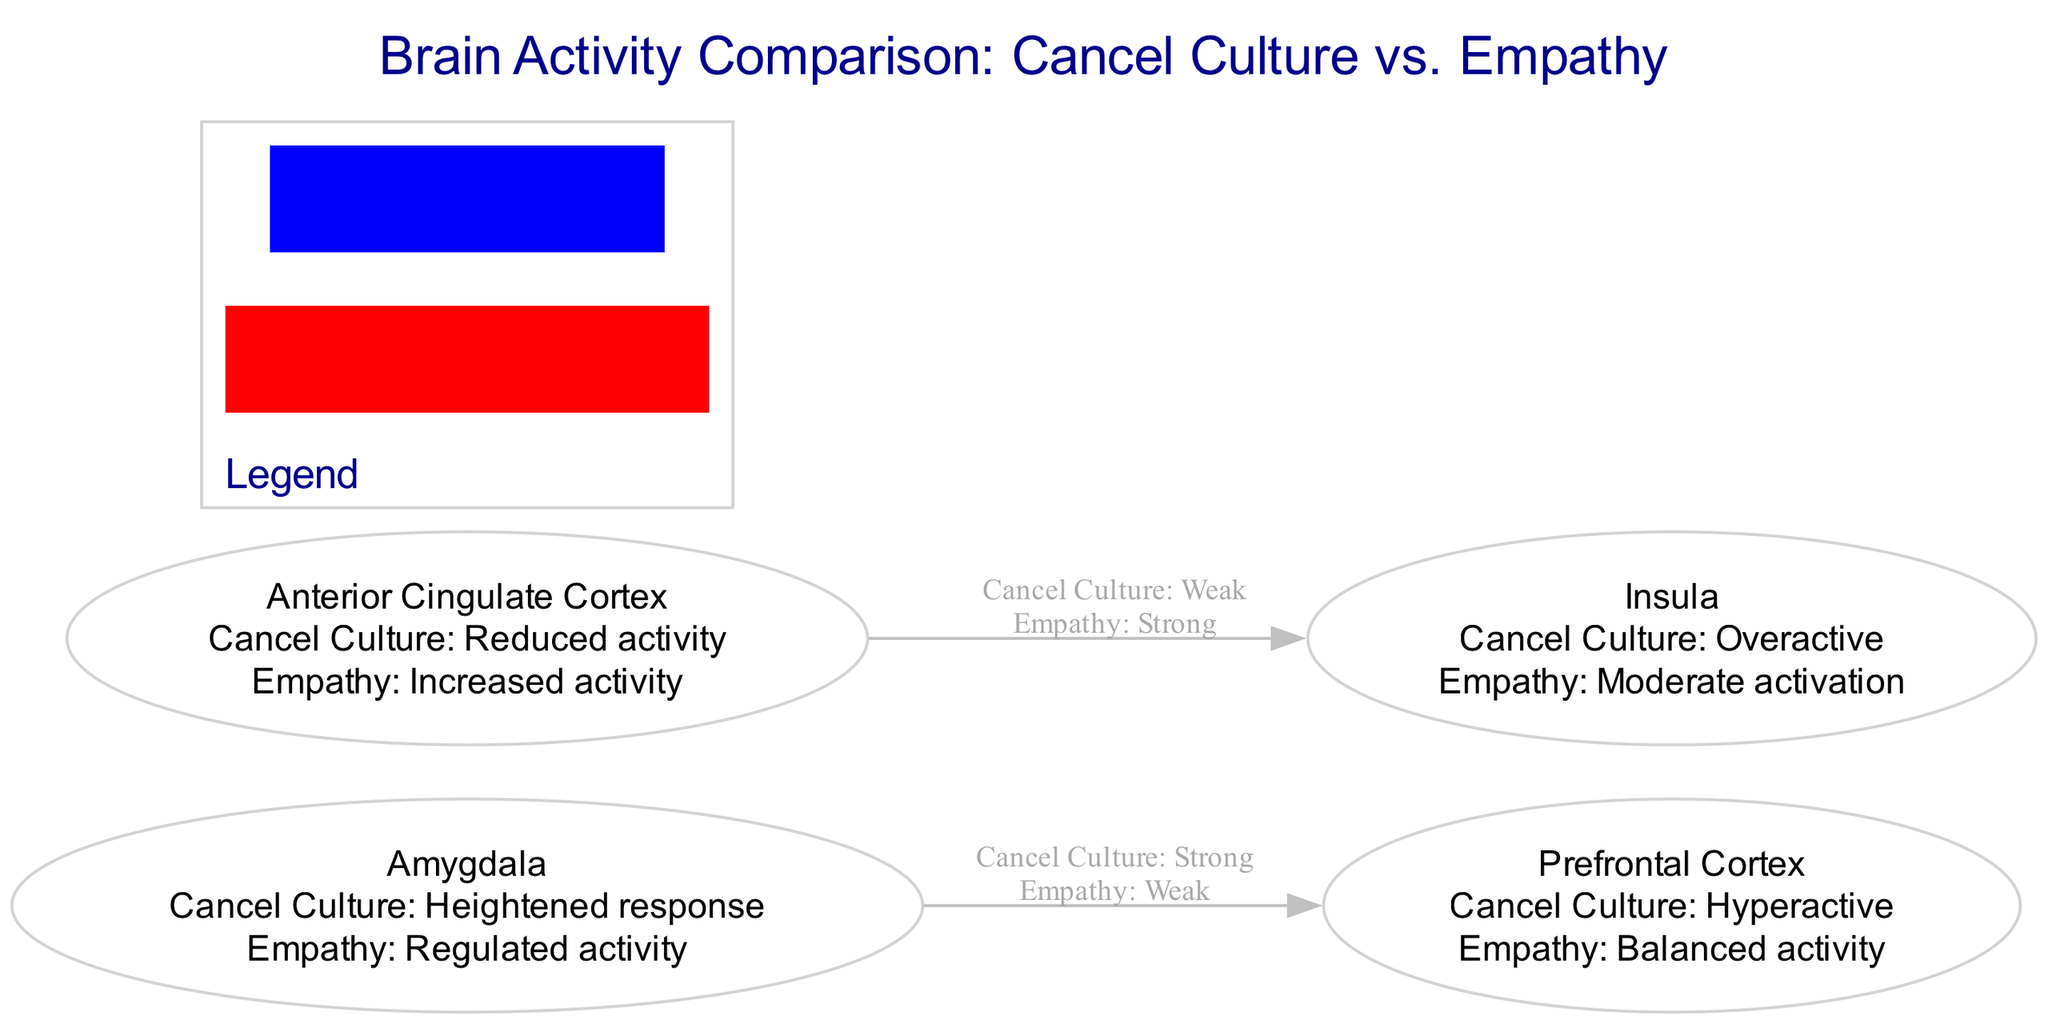What is the activity level in the Prefrontal Cortex for individuals engaged in cancel culture? The diagram indicates that the activity level in the Prefrontal Cortex for individuals engaged in cancel culture is "Hyperactive." This can be directly read from the label on the Prefrontal Cortex node.
Answer: Hyperactive What is the relationship between the Amygdala and the Prefrontal Cortex during cancel culture? The diagram shows a strong connection from the Amygdala to the Prefrontal Cortex during cancel culture. This is indicated by the strength label on the edge connecting these two nodes.
Answer: Strong How many brain regions are compared in the diagram? The diagram includes four brain regions: Prefrontal Cortex, Amygdala, Anterior Cingulate Cortex, and Insula. Counting these nodes gives a total of four.
Answer: 4 What type of activity is observed in the Anterior Cingulate Cortex during empathetic behavior? The activity level in the Anterior Cingulate Cortex during empathetic behavior is "Increased activity," as specified in the node's label.
Answer: Increased activity How does the Insula's activity differ between cancel culture and empathy? The Insula's activity during cancel culture is "Overactive," while during empathy it is at a "Moderate activation" level. The comparison across the two states provides the answer to this question.
Answer: Overactive, Moderate activation What does the red color in the legend signify in the context of this diagram? In the legend, the red color represents "Cancel culture brain activity." This specific detail is provided explicitly in the diagram's legend section.
Answer: Cancel culture brain activity Which connection is weak during empathetic behavior? The connection from the Anterior Cingulate Cortex to the Insula is labeled as "Weak" during empathetic behavior, according to the connection edge in the diagram.
Answer: Weak What is the activity level of the Amygdala for those practicing empathy? The activity level of the Amygdala for individuals practicing empathy is "Regulated activity," which is given in the corresponding node for the Amygdala.
Answer: Regulated activity What can be inferred about the connection strengths during cancel culture? During cancel culture, the connection from the Amygdala to the Prefrontal Cortex is strong, while the connection from the Anterior Cingulate Cortex to the Insula is weak. Combining these facts provides insight into the connection strengths during cancel culture behaviors.
Answer: Strong, Weak 